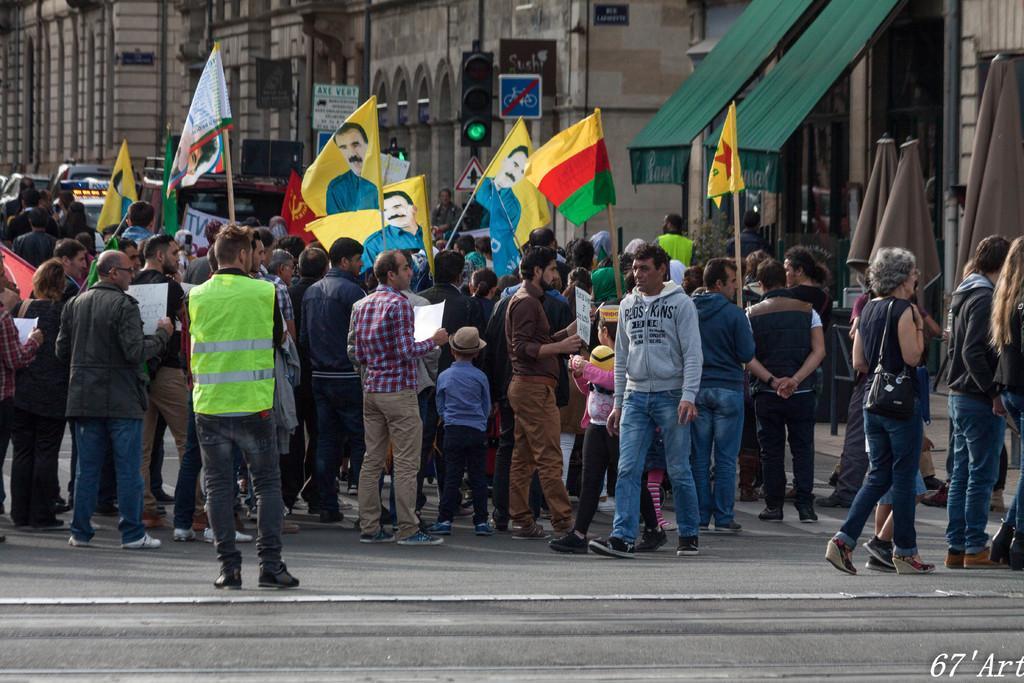In one or two sentences, can you explain what this image depicts? In the center of the image a group of people are standing. Some of them are holding flags and some of them are holding papers. At the top of the image we can see buildings, traffic lights, boards, tent, clothes, poles are there. At the bottom of the image road is there. 